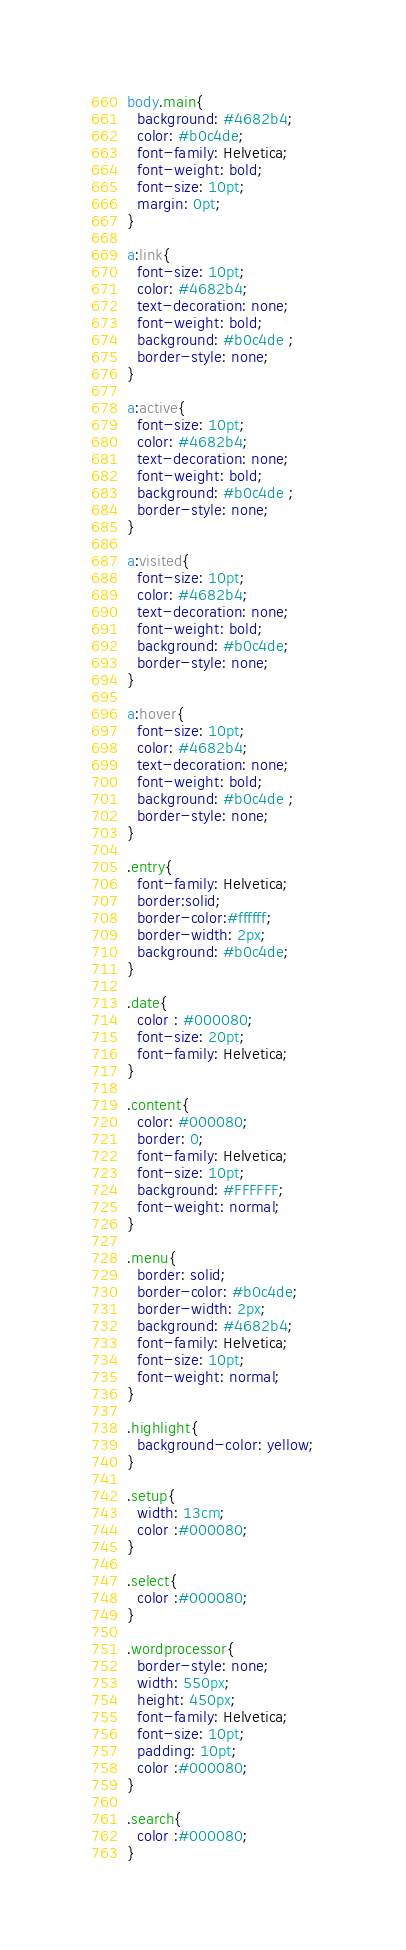Convert code to text. <code><loc_0><loc_0><loc_500><loc_500><_CSS_>body.main{
  background: #4682b4;
  color: #b0c4de;
  font-family: Helvetica;
  font-weight: bold;
  font-size: 10pt;
  margin: 0pt;
}

a:link{
  font-size: 10pt;
  color: #4682b4;
  text-decoration: none;
  font-weight: bold;
  background: #b0c4de ;
  border-style: none; 
}
          
a:active{ 
  font-size: 10pt;
  color: #4682b4;
  text-decoration: none;
  font-weight: bold;
  background: #b0c4de ;
  border-style: none;
}

a:visited{
  font-size: 10pt;
  color: #4682b4;
  text-decoration: none;
  font-weight: bold;
  background: #b0c4de;
  border-style: none;
} 

a:hover{
  font-size: 10pt;
  color: #4682b4;
  text-decoration: none;
  font-weight: bold;
  background: #b0c4de ;
  border-style: none;
}

.entry{
  font-family: Helvetica;
  border:solid;
  border-color:#ffffff;
  border-width: 2px;
  background: #b0c4de;
}

.date{
  color : #000080;
  font-size: 20pt;
  font-family: Helvetica;  
}

.content{
  color: #000080;
  border: 0;
  font-family: Helvetica;
  font-size: 10pt;
  background: #FFFFFF;
  font-weight: normal;
}

.menu{
  border: solid;
  border-color: #b0c4de;
  border-width: 2px;
  background: #4682b4;
  font-family: Helvetica;
  font-size: 10pt;
  font-weight: normal;
}

.highlight{
  background-color: yellow;
}

.setup{
  width: 13cm;
  color :#000080;
}

.select{
  color :#000080;
}

.wordprocessor{
  border-style: none;
  width: 550px;
  height: 450px;
  font-family: Helvetica;
  font-size: 10pt;
  padding: 10pt;
  color :#000080;
}

.search{
  color :#000080;
}</code> 